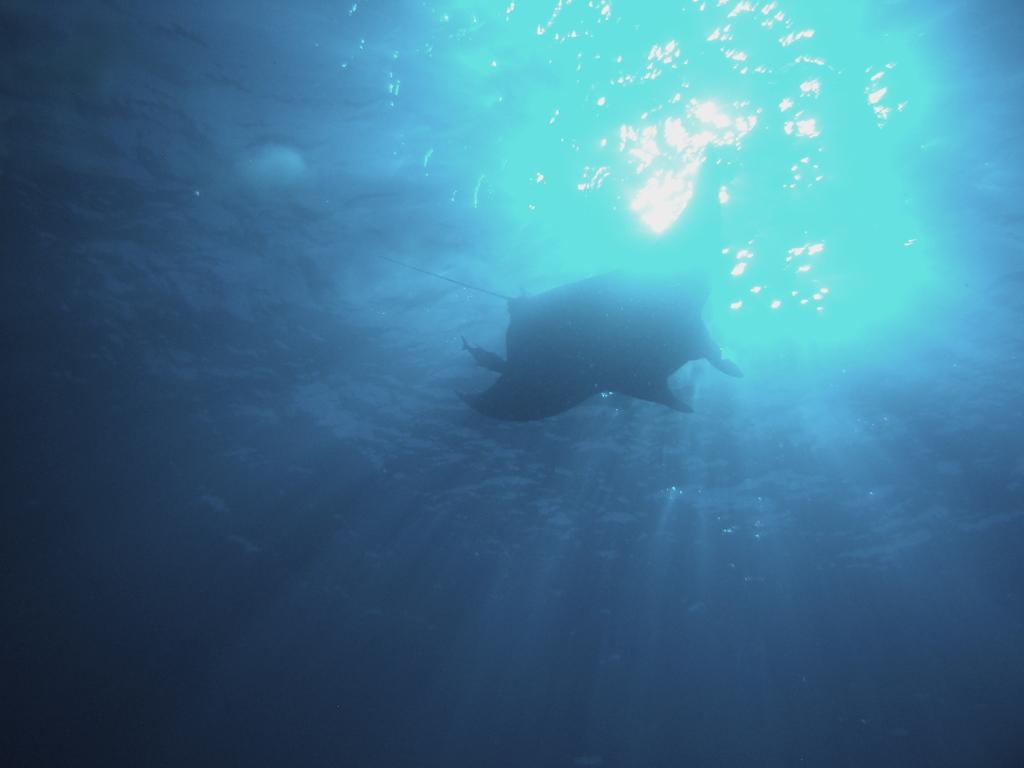What type of animals can be seen in the image? Fishes can be seen in the water. Where are the fishes located in the image? The fishes are in the water. What is the condition of the fifth group of fishes in the image? There is no mention of a fifth group of fishes in the image, as there is only one fact provided, which states that there are fishes in the water. 